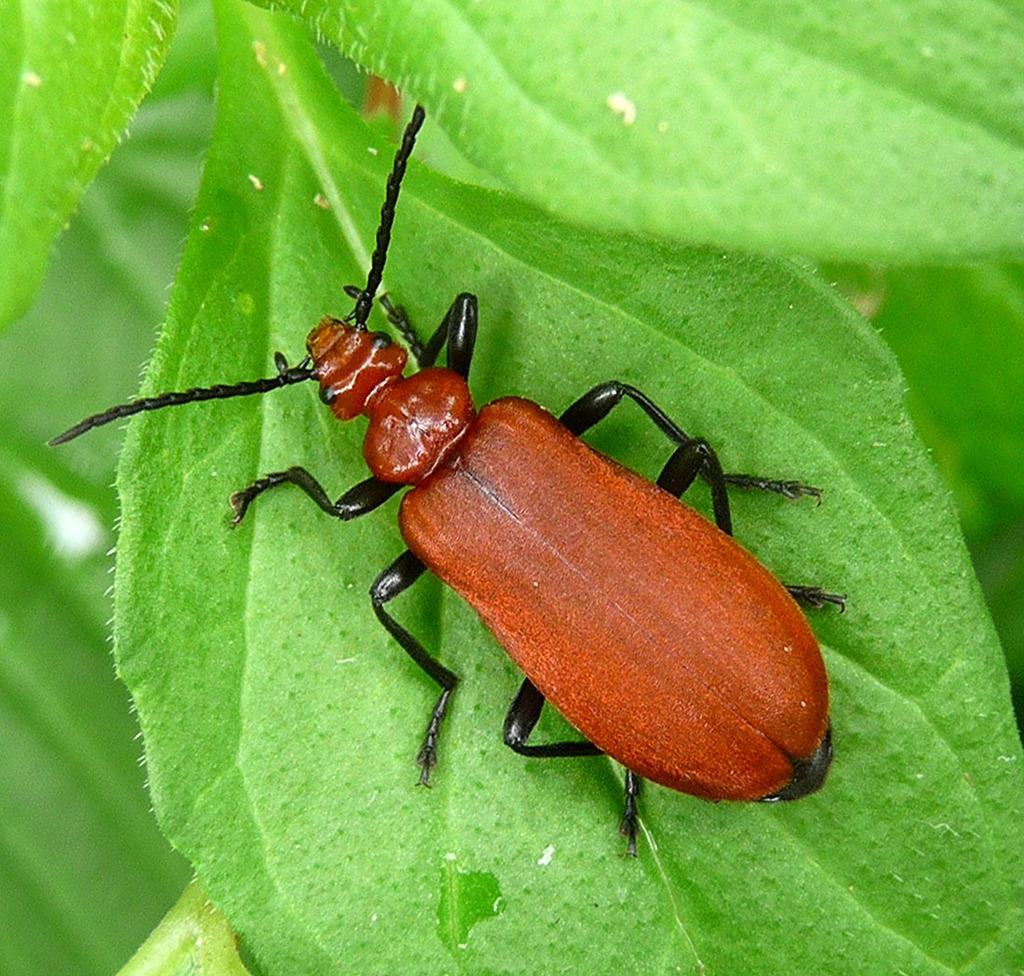What type of creature is in the image? There is an insect in the image. What colors can be seen on the insect? The insect has brown, orange, and black colors. Where is the insect located in the image? The insect is on a leaf. What color is the leaf the insect is on? The leaf is green in color. Are there any other green leaves visible in the image? Yes, there are other green leaves in the image. How does the insect grip the appliance in the image? There is no appliance present in the image; the insect is on a leaf. 